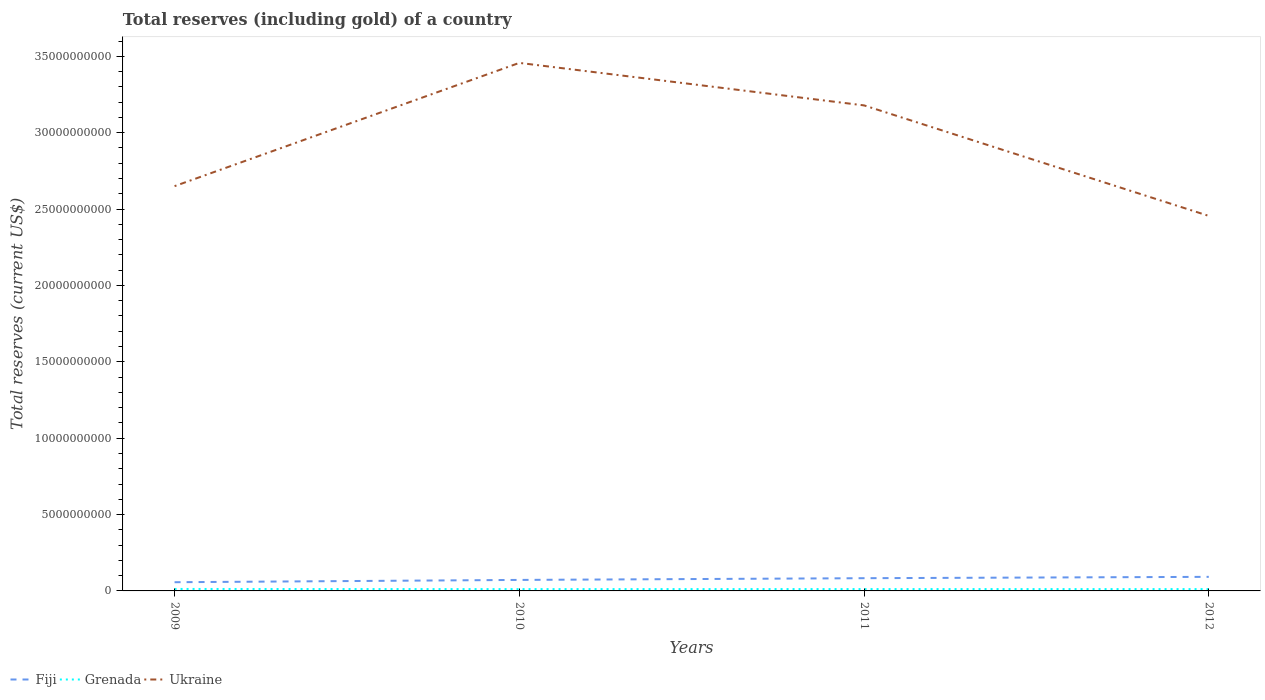Is the number of lines equal to the number of legend labels?
Keep it short and to the point. Yes. Across all years, what is the maximum total reserves (including gold) in Grenada?
Your answer should be very brief. 1.19e+08. In which year was the total reserves (including gold) in Grenada maximum?
Your answer should be compact. 2010. What is the total total reserves (including gold) in Grenada in the graph?
Ensure brevity in your answer.  9.59e+06. What is the difference between the highest and the second highest total reserves (including gold) in Fiji?
Keep it short and to the point. 3.51e+08. What is the difference between the highest and the lowest total reserves (including gold) in Fiji?
Provide a short and direct response. 2. Is the total reserves (including gold) in Grenada strictly greater than the total reserves (including gold) in Ukraine over the years?
Ensure brevity in your answer.  Yes. How many lines are there?
Keep it short and to the point. 3. What is the difference between two consecutive major ticks on the Y-axis?
Provide a succinct answer. 5.00e+09. Are the values on the major ticks of Y-axis written in scientific E-notation?
Provide a short and direct response. No. Does the graph contain grids?
Provide a short and direct response. No. What is the title of the graph?
Your answer should be compact. Total reserves (including gold) of a country. What is the label or title of the Y-axis?
Keep it short and to the point. Total reserves (current US$). What is the Total reserves (current US$) of Fiji in 2009?
Your answer should be very brief. 5.70e+08. What is the Total reserves (current US$) in Grenada in 2009?
Make the answer very short. 1.29e+08. What is the Total reserves (current US$) in Ukraine in 2009?
Your answer should be very brief. 2.65e+1. What is the Total reserves (current US$) in Fiji in 2010?
Offer a terse response. 7.21e+08. What is the Total reserves (current US$) in Grenada in 2010?
Your answer should be compact. 1.19e+08. What is the Total reserves (current US$) of Ukraine in 2010?
Your response must be concise. 3.46e+1. What is the Total reserves (current US$) of Fiji in 2011?
Keep it short and to the point. 8.33e+08. What is the Total reserves (current US$) of Grenada in 2011?
Keep it short and to the point. 1.21e+08. What is the Total reserves (current US$) of Ukraine in 2011?
Give a very brief answer. 3.18e+1. What is the Total reserves (current US$) in Fiji in 2012?
Your answer should be very brief. 9.21e+08. What is the Total reserves (current US$) of Grenada in 2012?
Your answer should be very brief. 1.19e+08. What is the Total reserves (current US$) of Ukraine in 2012?
Your response must be concise. 2.46e+1. Across all years, what is the maximum Total reserves (current US$) in Fiji?
Give a very brief answer. 9.21e+08. Across all years, what is the maximum Total reserves (current US$) of Grenada?
Your answer should be very brief. 1.29e+08. Across all years, what is the maximum Total reserves (current US$) in Ukraine?
Provide a short and direct response. 3.46e+1. Across all years, what is the minimum Total reserves (current US$) in Fiji?
Offer a very short reply. 5.70e+08. Across all years, what is the minimum Total reserves (current US$) in Grenada?
Provide a succinct answer. 1.19e+08. Across all years, what is the minimum Total reserves (current US$) in Ukraine?
Offer a very short reply. 2.46e+1. What is the total Total reserves (current US$) in Fiji in the graph?
Ensure brevity in your answer.  3.05e+09. What is the total Total reserves (current US$) in Grenada in the graph?
Provide a short and direct response. 4.88e+08. What is the total Total reserves (current US$) of Ukraine in the graph?
Offer a terse response. 1.17e+11. What is the difference between the Total reserves (current US$) in Fiji in 2009 and that in 2010?
Provide a succinct answer. -1.51e+08. What is the difference between the Total reserves (current US$) in Grenada in 2009 and that in 2010?
Offer a very short reply. 9.92e+06. What is the difference between the Total reserves (current US$) in Ukraine in 2009 and that in 2010?
Provide a succinct answer. -8.07e+09. What is the difference between the Total reserves (current US$) of Fiji in 2009 and that in 2011?
Keep it short and to the point. -2.63e+08. What is the difference between the Total reserves (current US$) in Grenada in 2009 and that in 2011?
Your answer should be very brief. 8.37e+06. What is the difference between the Total reserves (current US$) of Ukraine in 2009 and that in 2011?
Your answer should be very brief. -5.29e+09. What is the difference between the Total reserves (current US$) in Fiji in 2009 and that in 2012?
Make the answer very short. -3.51e+08. What is the difference between the Total reserves (current US$) of Grenada in 2009 and that in 2012?
Make the answer very short. 9.59e+06. What is the difference between the Total reserves (current US$) of Ukraine in 2009 and that in 2012?
Offer a terse response. 1.95e+09. What is the difference between the Total reserves (current US$) of Fiji in 2010 and that in 2011?
Give a very brief answer. -1.13e+08. What is the difference between the Total reserves (current US$) in Grenada in 2010 and that in 2011?
Ensure brevity in your answer.  -1.56e+06. What is the difference between the Total reserves (current US$) of Ukraine in 2010 and that in 2011?
Your answer should be compact. 2.78e+09. What is the difference between the Total reserves (current US$) of Fiji in 2010 and that in 2012?
Your response must be concise. -2.01e+08. What is the difference between the Total reserves (current US$) in Grenada in 2010 and that in 2012?
Make the answer very short. -3.30e+05. What is the difference between the Total reserves (current US$) in Ukraine in 2010 and that in 2012?
Provide a succinct answer. 1.00e+1. What is the difference between the Total reserves (current US$) of Fiji in 2011 and that in 2012?
Your answer should be very brief. -8.79e+07. What is the difference between the Total reserves (current US$) of Grenada in 2011 and that in 2012?
Provide a succinct answer. 1.23e+06. What is the difference between the Total reserves (current US$) in Ukraine in 2011 and that in 2012?
Ensure brevity in your answer.  7.24e+09. What is the difference between the Total reserves (current US$) in Fiji in 2009 and the Total reserves (current US$) in Grenada in 2010?
Your answer should be compact. 4.51e+08. What is the difference between the Total reserves (current US$) in Fiji in 2009 and the Total reserves (current US$) in Ukraine in 2010?
Ensure brevity in your answer.  -3.40e+1. What is the difference between the Total reserves (current US$) in Grenada in 2009 and the Total reserves (current US$) in Ukraine in 2010?
Keep it short and to the point. -3.44e+1. What is the difference between the Total reserves (current US$) in Fiji in 2009 and the Total reserves (current US$) in Grenada in 2011?
Provide a short and direct response. 4.49e+08. What is the difference between the Total reserves (current US$) of Fiji in 2009 and the Total reserves (current US$) of Ukraine in 2011?
Make the answer very short. -3.12e+1. What is the difference between the Total reserves (current US$) in Grenada in 2009 and the Total reserves (current US$) in Ukraine in 2011?
Ensure brevity in your answer.  -3.17e+1. What is the difference between the Total reserves (current US$) of Fiji in 2009 and the Total reserves (current US$) of Grenada in 2012?
Your answer should be compact. 4.51e+08. What is the difference between the Total reserves (current US$) of Fiji in 2009 and the Total reserves (current US$) of Ukraine in 2012?
Ensure brevity in your answer.  -2.40e+1. What is the difference between the Total reserves (current US$) of Grenada in 2009 and the Total reserves (current US$) of Ukraine in 2012?
Your answer should be compact. -2.44e+1. What is the difference between the Total reserves (current US$) of Fiji in 2010 and the Total reserves (current US$) of Grenada in 2011?
Your answer should be compact. 6.00e+08. What is the difference between the Total reserves (current US$) in Fiji in 2010 and the Total reserves (current US$) in Ukraine in 2011?
Your answer should be very brief. -3.11e+1. What is the difference between the Total reserves (current US$) in Grenada in 2010 and the Total reserves (current US$) in Ukraine in 2011?
Provide a succinct answer. -3.17e+1. What is the difference between the Total reserves (current US$) in Fiji in 2010 and the Total reserves (current US$) in Grenada in 2012?
Make the answer very short. 6.01e+08. What is the difference between the Total reserves (current US$) of Fiji in 2010 and the Total reserves (current US$) of Ukraine in 2012?
Your response must be concise. -2.38e+1. What is the difference between the Total reserves (current US$) of Grenada in 2010 and the Total reserves (current US$) of Ukraine in 2012?
Offer a terse response. -2.44e+1. What is the difference between the Total reserves (current US$) of Fiji in 2011 and the Total reserves (current US$) of Grenada in 2012?
Your answer should be compact. 7.14e+08. What is the difference between the Total reserves (current US$) in Fiji in 2011 and the Total reserves (current US$) in Ukraine in 2012?
Provide a short and direct response. -2.37e+1. What is the difference between the Total reserves (current US$) in Grenada in 2011 and the Total reserves (current US$) in Ukraine in 2012?
Your response must be concise. -2.44e+1. What is the average Total reserves (current US$) of Fiji per year?
Make the answer very short. 7.61e+08. What is the average Total reserves (current US$) of Grenada per year?
Ensure brevity in your answer.  1.22e+08. What is the average Total reserves (current US$) in Ukraine per year?
Your response must be concise. 2.94e+1. In the year 2009, what is the difference between the Total reserves (current US$) of Fiji and Total reserves (current US$) of Grenada?
Provide a succinct answer. 4.41e+08. In the year 2009, what is the difference between the Total reserves (current US$) of Fiji and Total reserves (current US$) of Ukraine?
Provide a short and direct response. -2.59e+1. In the year 2009, what is the difference between the Total reserves (current US$) of Grenada and Total reserves (current US$) of Ukraine?
Keep it short and to the point. -2.64e+1. In the year 2010, what is the difference between the Total reserves (current US$) in Fiji and Total reserves (current US$) in Grenada?
Your answer should be compact. 6.01e+08. In the year 2010, what is the difference between the Total reserves (current US$) in Fiji and Total reserves (current US$) in Ukraine?
Provide a succinct answer. -3.39e+1. In the year 2010, what is the difference between the Total reserves (current US$) in Grenada and Total reserves (current US$) in Ukraine?
Ensure brevity in your answer.  -3.45e+1. In the year 2011, what is the difference between the Total reserves (current US$) in Fiji and Total reserves (current US$) in Grenada?
Give a very brief answer. 7.13e+08. In the year 2011, what is the difference between the Total reserves (current US$) in Fiji and Total reserves (current US$) in Ukraine?
Give a very brief answer. -3.10e+1. In the year 2011, what is the difference between the Total reserves (current US$) in Grenada and Total reserves (current US$) in Ukraine?
Offer a terse response. -3.17e+1. In the year 2012, what is the difference between the Total reserves (current US$) of Fiji and Total reserves (current US$) of Grenada?
Keep it short and to the point. 8.02e+08. In the year 2012, what is the difference between the Total reserves (current US$) of Fiji and Total reserves (current US$) of Ukraine?
Ensure brevity in your answer.  -2.36e+1. In the year 2012, what is the difference between the Total reserves (current US$) in Grenada and Total reserves (current US$) in Ukraine?
Your answer should be very brief. -2.44e+1. What is the ratio of the Total reserves (current US$) in Fiji in 2009 to that in 2010?
Ensure brevity in your answer.  0.79. What is the ratio of the Total reserves (current US$) of Ukraine in 2009 to that in 2010?
Offer a very short reply. 0.77. What is the ratio of the Total reserves (current US$) of Fiji in 2009 to that in 2011?
Provide a succinct answer. 0.68. What is the ratio of the Total reserves (current US$) in Grenada in 2009 to that in 2011?
Make the answer very short. 1.07. What is the ratio of the Total reserves (current US$) of Ukraine in 2009 to that in 2011?
Keep it short and to the point. 0.83. What is the ratio of the Total reserves (current US$) in Fiji in 2009 to that in 2012?
Ensure brevity in your answer.  0.62. What is the ratio of the Total reserves (current US$) in Grenada in 2009 to that in 2012?
Your response must be concise. 1.08. What is the ratio of the Total reserves (current US$) of Ukraine in 2009 to that in 2012?
Keep it short and to the point. 1.08. What is the ratio of the Total reserves (current US$) of Fiji in 2010 to that in 2011?
Make the answer very short. 0.86. What is the ratio of the Total reserves (current US$) in Grenada in 2010 to that in 2011?
Provide a succinct answer. 0.99. What is the ratio of the Total reserves (current US$) in Ukraine in 2010 to that in 2011?
Provide a short and direct response. 1.09. What is the ratio of the Total reserves (current US$) of Fiji in 2010 to that in 2012?
Provide a succinct answer. 0.78. What is the ratio of the Total reserves (current US$) in Grenada in 2010 to that in 2012?
Ensure brevity in your answer.  1. What is the ratio of the Total reserves (current US$) in Ukraine in 2010 to that in 2012?
Your response must be concise. 1.41. What is the ratio of the Total reserves (current US$) in Fiji in 2011 to that in 2012?
Your answer should be compact. 0.9. What is the ratio of the Total reserves (current US$) in Grenada in 2011 to that in 2012?
Your answer should be very brief. 1.01. What is the ratio of the Total reserves (current US$) in Ukraine in 2011 to that in 2012?
Your answer should be very brief. 1.29. What is the difference between the highest and the second highest Total reserves (current US$) in Fiji?
Offer a very short reply. 8.79e+07. What is the difference between the highest and the second highest Total reserves (current US$) of Grenada?
Offer a very short reply. 8.37e+06. What is the difference between the highest and the second highest Total reserves (current US$) in Ukraine?
Provide a succinct answer. 2.78e+09. What is the difference between the highest and the lowest Total reserves (current US$) of Fiji?
Your answer should be compact. 3.51e+08. What is the difference between the highest and the lowest Total reserves (current US$) of Grenada?
Offer a very short reply. 9.92e+06. What is the difference between the highest and the lowest Total reserves (current US$) in Ukraine?
Make the answer very short. 1.00e+1. 